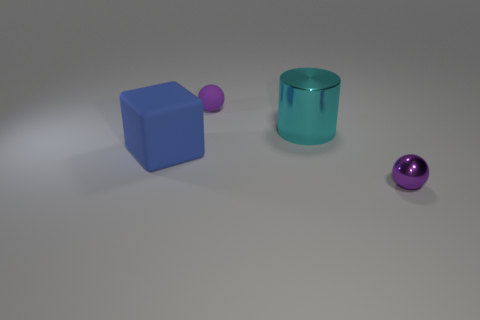Subtract all cylinders. How many objects are left? 3 Subtract 2 balls. How many balls are left? 0 Add 1 big matte cubes. How many objects exist? 5 Subtract 0 red cylinders. How many objects are left? 4 Subtract all yellow cylinders. Subtract all yellow cubes. How many cylinders are left? 1 Subtract all tiny red cylinders. Subtract all metal balls. How many objects are left? 3 Add 2 big cyan things. How many big cyan things are left? 3 Add 2 cyan cylinders. How many cyan cylinders exist? 3 